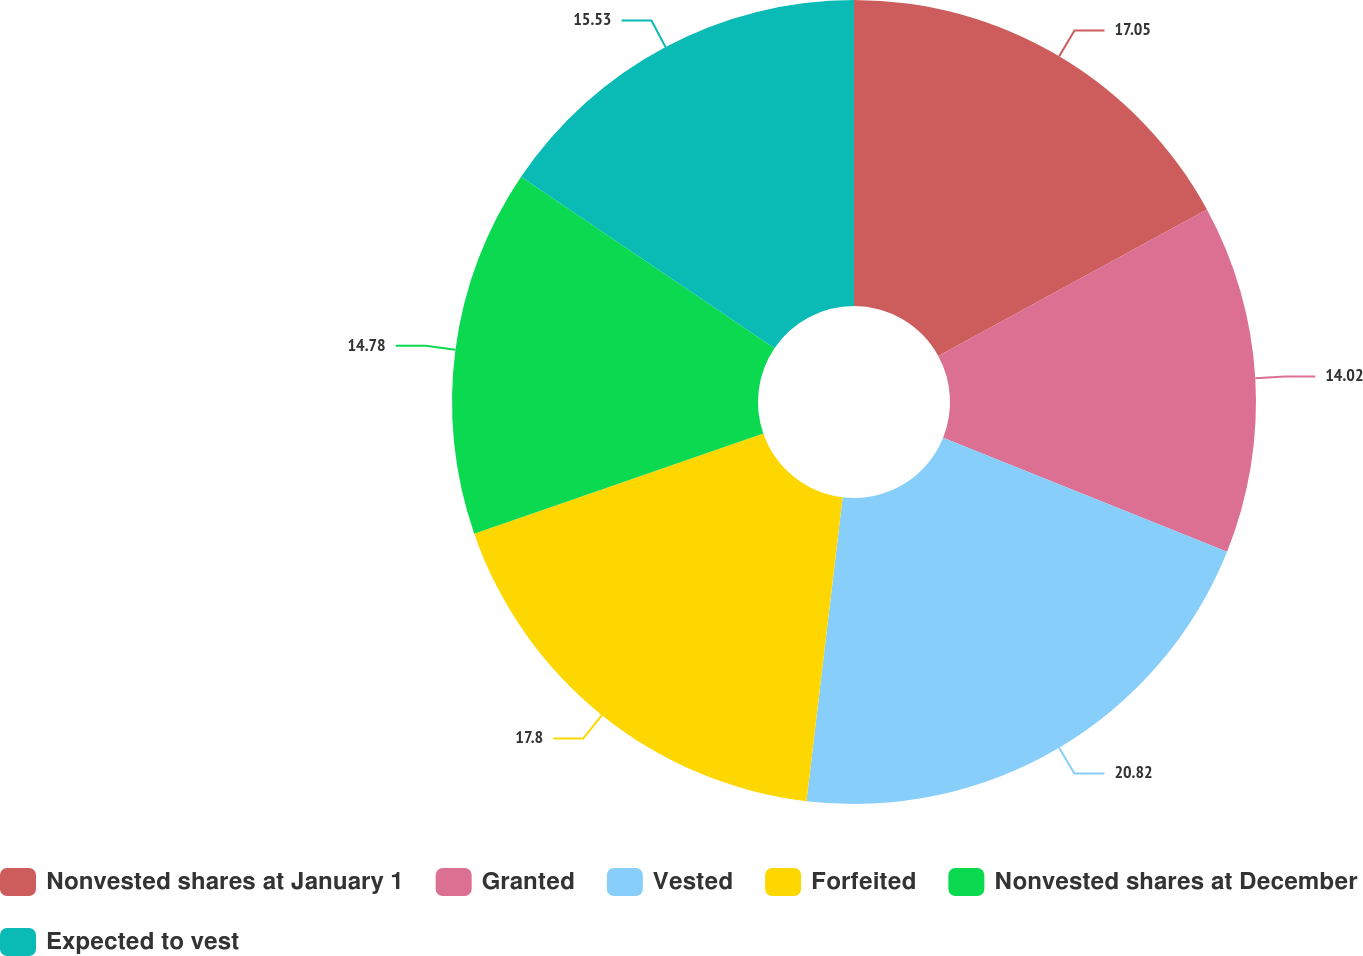Convert chart. <chart><loc_0><loc_0><loc_500><loc_500><pie_chart><fcel>Nonvested shares at January 1<fcel>Granted<fcel>Vested<fcel>Forfeited<fcel>Nonvested shares at December<fcel>Expected to vest<nl><fcel>17.05%<fcel>14.02%<fcel>20.81%<fcel>17.8%<fcel>14.78%<fcel>15.53%<nl></chart> 